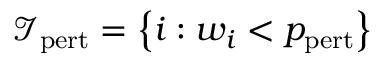Convert formula to latex. <formula><loc_0><loc_0><loc_500><loc_500>\mathcal { I } _ { p e r t } = \left \{ i \colon w _ { i } < p _ { p e r t } \right \}</formula> 